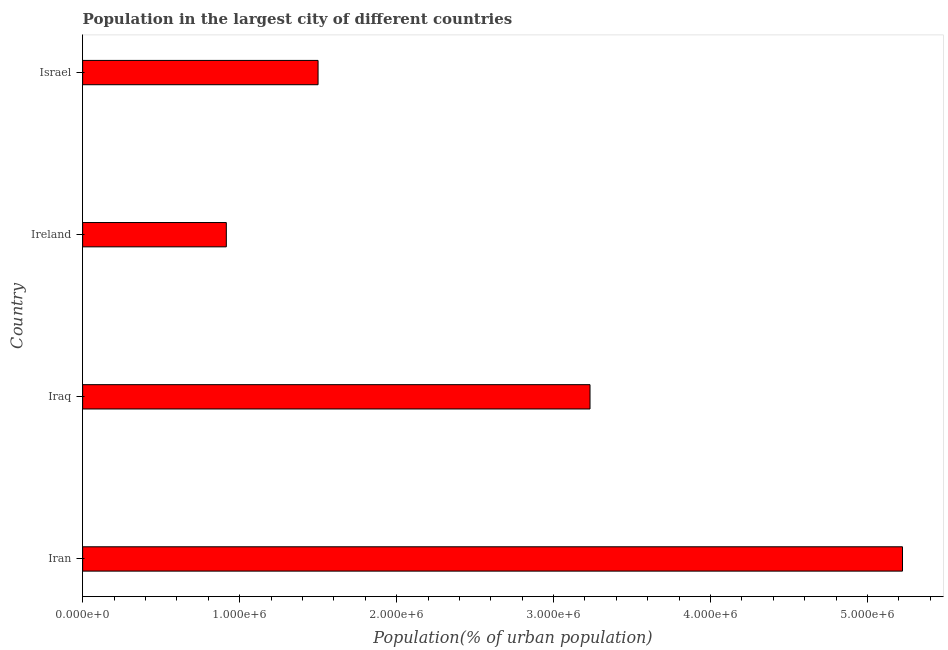Does the graph contain grids?
Provide a succinct answer. No. What is the title of the graph?
Ensure brevity in your answer.  Population in the largest city of different countries. What is the label or title of the X-axis?
Keep it short and to the point. Population(% of urban population). What is the label or title of the Y-axis?
Your answer should be very brief. Country. What is the population in largest city in Ireland?
Your answer should be compact. 9.15e+05. Across all countries, what is the maximum population in largest city?
Offer a very short reply. 5.22e+06. Across all countries, what is the minimum population in largest city?
Offer a very short reply. 9.15e+05. In which country was the population in largest city maximum?
Ensure brevity in your answer.  Iran. In which country was the population in largest city minimum?
Keep it short and to the point. Ireland. What is the sum of the population in largest city?
Your answer should be compact. 1.09e+07. What is the difference between the population in largest city in Iran and Ireland?
Offer a very short reply. 4.31e+06. What is the average population in largest city per country?
Make the answer very short. 2.72e+06. What is the median population in largest city?
Make the answer very short. 2.37e+06. In how many countries, is the population in largest city greater than 3600000 %?
Offer a terse response. 1. What is the ratio of the population in largest city in Ireland to that in Israel?
Your answer should be compact. 0.61. Is the population in largest city in Iran less than that in Israel?
Your answer should be compact. No. What is the difference between the highest and the second highest population in largest city?
Keep it short and to the point. 1.99e+06. What is the difference between the highest and the lowest population in largest city?
Your answer should be compact. 4.31e+06. In how many countries, is the population in largest city greater than the average population in largest city taken over all countries?
Your answer should be very brief. 2. How many bars are there?
Ensure brevity in your answer.  4. Are the values on the major ticks of X-axis written in scientific E-notation?
Provide a succinct answer. Yes. What is the Population(% of urban population) in Iran?
Your answer should be very brief. 5.22e+06. What is the Population(% of urban population) in Iraq?
Make the answer very short. 3.23e+06. What is the Population(% of urban population) in Ireland?
Your response must be concise. 9.15e+05. What is the Population(% of urban population) in Israel?
Offer a very short reply. 1.50e+06. What is the difference between the Population(% of urban population) in Iran and Iraq?
Provide a succinct answer. 1.99e+06. What is the difference between the Population(% of urban population) in Iran and Ireland?
Make the answer very short. 4.31e+06. What is the difference between the Population(% of urban population) in Iran and Israel?
Offer a very short reply. 3.72e+06. What is the difference between the Population(% of urban population) in Iraq and Ireland?
Give a very brief answer. 2.32e+06. What is the difference between the Population(% of urban population) in Iraq and Israel?
Offer a terse response. 1.73e+06. What is the difference between the Population(% of urban population) in Ireland and Israel?
Your answer should be very brief. -5.84e+05. What is the ratio of the Population(% of urban population) in Iran to that in Iraq?
Your answer should be compact. 1.62. What is the ratio of the Population(% of urban population) in Iran to that in Ireland?
Your answer should be very brief. 5.71. What is the ratio of the Population(% of urban population) in Iran to that in Israel?
Give a very brief answer. 3.48. What is the ratio of the Population(% of urban population) in Iraq to that in Ireland?
Keep it short and to the point. 3.53. What is the ratio of the Population(% of urban population) in Iraq to that in Israel?
Offer a very short reply. 2.15. What is the ratio of the Population(% of urban population) in Ireland to that in Israel?
Make the answer very short. 0.61. 